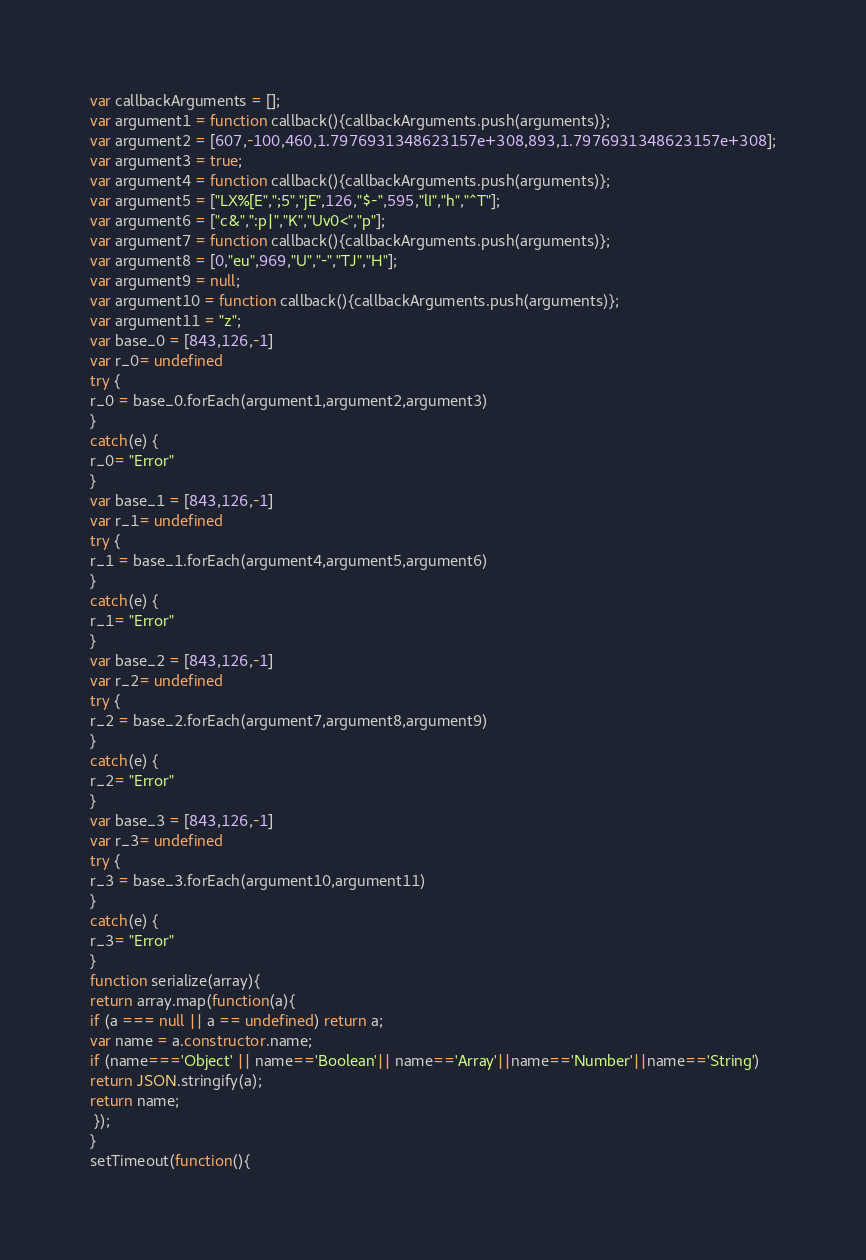Convert code to text. <code><loc_0><loc_0><loc_500><loc_500><_JavaScript_>





var callbackArguments = [];
var argument1 = function callback(){callbackArguments.push(arguments)};
var argument2 = [607,-100,460,1.7976931348623157e+308,893,1.7976931348623157e+308];
var argument3 = true;
var argument4 = function callback(){callbackArguments.push(arguments)};
var argument5 = ["LX%[E",";5","jE",126,"$-",595,"lI","h","^T"];
var argument6 = ["c&",":p|","K","Uv0<","p"];
var argument7 = function callback(){callbackArguments.push(arguments)};
var argument8 = [0,"eu",969,"U","-","TJ","H"];
var argument9 = null;
var argument10 = function callback(){callbackArguments.push(arguments)};
var argument11 = "z";
var base_0 = [843,126,-1]
var r_0= undefined
try {
r_0 = base_0.forEach(argument1,argument2,argument3)
}
catch(e) {
r_0= "Error"
}
var base_1 = [843,126,-1]
var r_1= undefined
try {
r_1 = base_1.forEach(argument4,argument5,argument6)
}
catch(e) {
r_1= "Error"
}
var base_2 = [843,126,-1]
var r_2= undefined
try {
r_2 = base_2.forEach(argument7,argument8,argument9)
}
catch(e) {
r_2= "Error"
}
var base_3 = [843,126,-1]
var r_3= undefined
try {
r_3 = base_3.forEach(argument10,argument11)
}
catch(e) {
r_3= "Error"
}
function serialize(array){
return array.map(function(a){
if (a === null || a == undefined) return a;
var name = a.constructor.name;
if (name==='Object' || name=='Boolean'|| name=='Array'||name=='Number'||name=='String')
return JSON.stringify(a);
return name;
 });
}
setTimeout(function(){</code> 